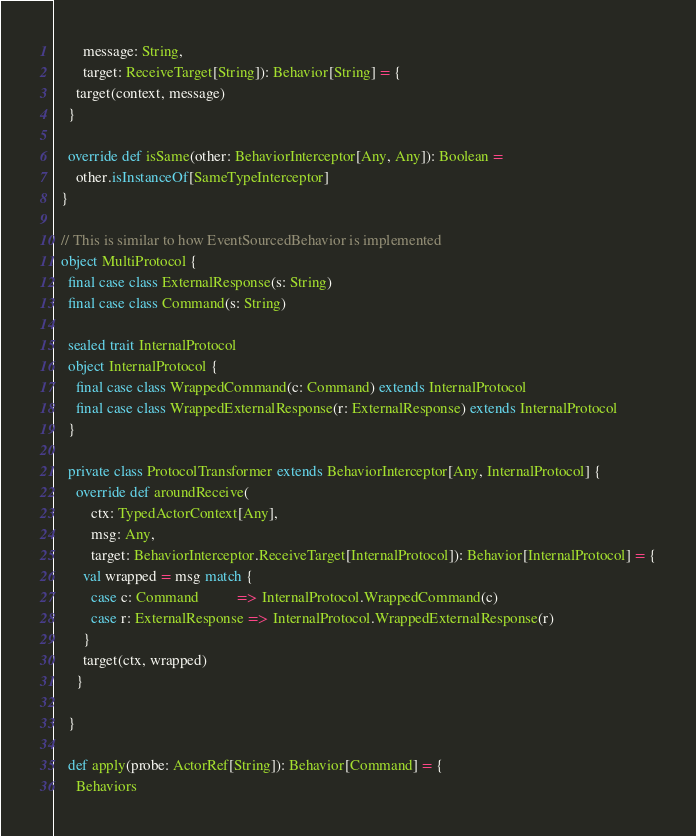Convert code to text. <code><loc_0><loc_0><loc_500><loc_500><_Scala_>        message: String,
        target: ReceiveTarget[String]): Behavior[String] = {
      target(context, message)
    }

    override def isSame(other: BehaviorInterceptor[Any, Any]): Boolean =
      other.isInstanceOf[SameTypeInterceptor]
  }

  // This is similar to how EventSourcedBehavior is implemented
  object MultiProtocol {
    final case class ExternalResponse(s: String)
    final case class Command(s: String)

    sealed trait InternalProtocol
    object InternalProtocol {
      final case class WrappedCommand(c: Command) extends InternalProtocol
      final case class WrappedExternalResponse(r: ExternalResponse) extends InternalProtocol
    }

    private class ProtocolTransformer extends BehaviorInterceptor[Any, InternalProtocol] {
      override def aroundReceive(
          ctx: TypedActorContext[Any],
          msg: Any,
          target: BehaviorInterceptor.ReceiveTarget[InternalProtocol]): Behavior[InternalProtocol] = {
        val wrapped = msg match {
          case c: Command          => InternalProtocol.WrappedCommand(c)
          case r: ExternalResponse => InternalProtocol.WrappedExternalResponse(r)
        }
        target(ctx, wrapped)
      }

    }

    def apply(probe: ActorRef[String]): Behavior[Command] = {
      Behaviors</code> 